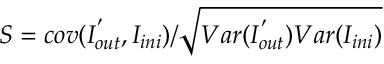Convert formula to latex. <formula><loc_0><loc_0><loc_500><loc_500>S = c o v ( { I } _ { o u t } ^ { ^ { \prime } } , { I } _ { i n i } ) / \sqrt { V a r ( { I } _ { o u t } ^ { ^ { \prime } } ) V a r ( { I } _ { i n i } ) }</formula> 